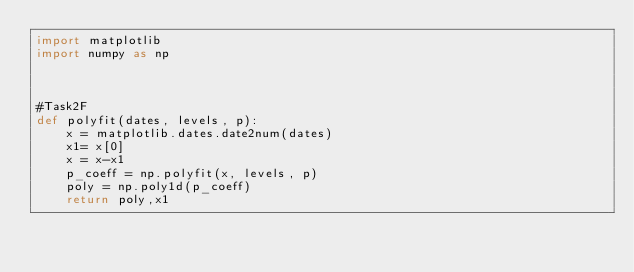Convert code to text. <code><loc_0><loc_0><loc_500><loc_500><_Python_>import matplotlib
import numpy as np



#Task2F
def polyfit(dates, levels, p):
    x = matplotlib.dates.date2num(dates)
    x1= x[0]
    x = x-x1
    p_coeff = np.polyfit(x, levels, p)
    poly = np.poly1d(p_coeff)
    return poly,x1

</code> 